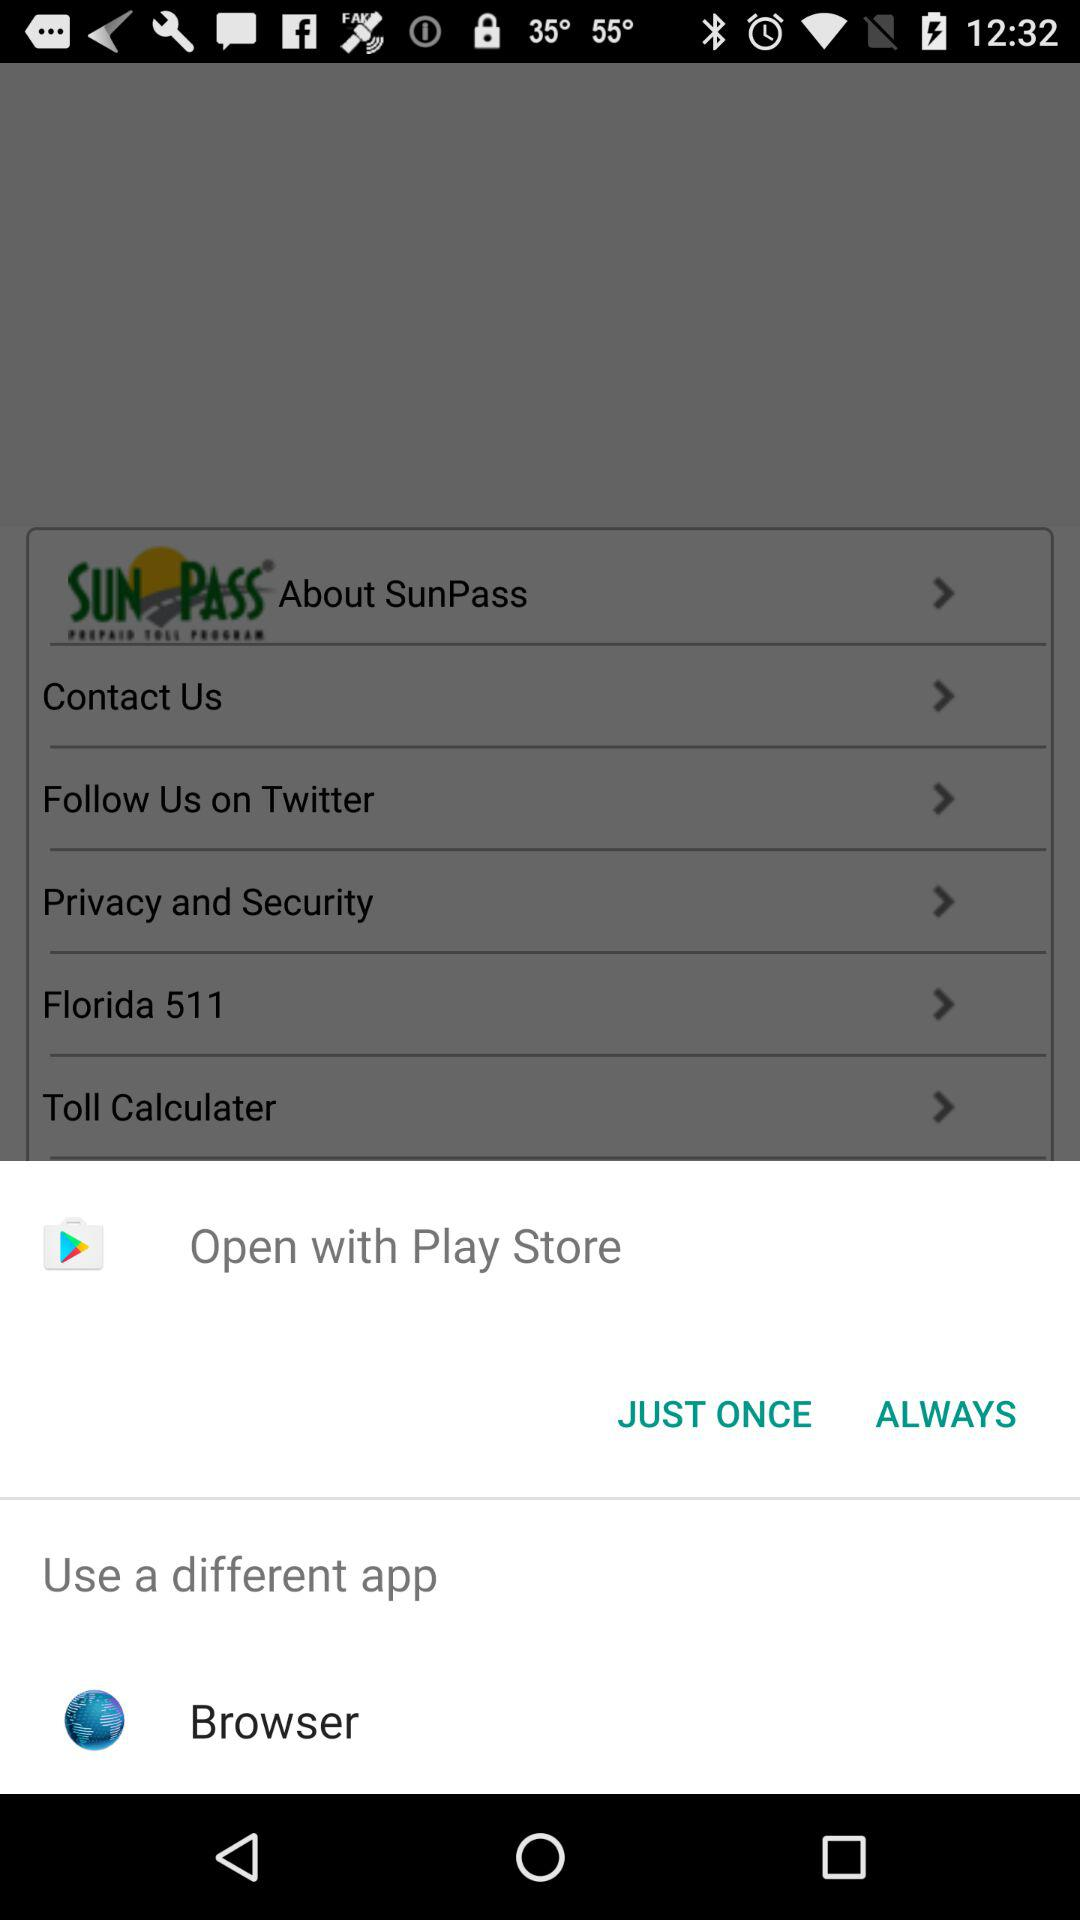By which app can we open it? You can open it with "Play Store" and "Browser". 